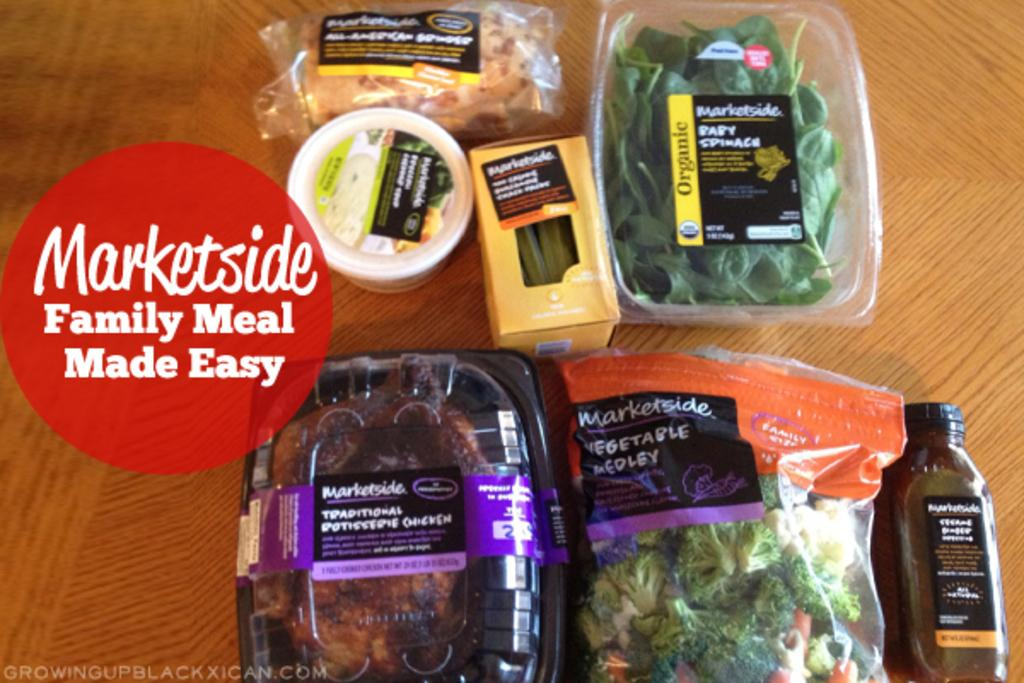<image>
Render a clear and concise summary of the photo. An advertisement for a market showing packages of various foods on a wooden table. 